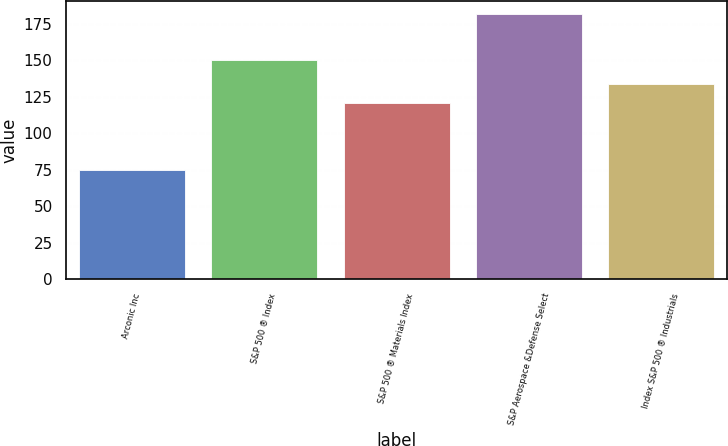Convert chart. <chart><loc_0><loc_0><loc_500><loc_500><bar_chart><fcel>Arconic Inc<fcel>S&P 500 ® Index<fcel>S&P 500 ® Materials Index<fcel>S&P Aerospace &Defense Select<fcel>Index S&P 500 ® Industrials<nl><fcel>74.47<fcel>150.33<fcel>120.74<fcel>181.56<fcel>133.53<nl></chart> 